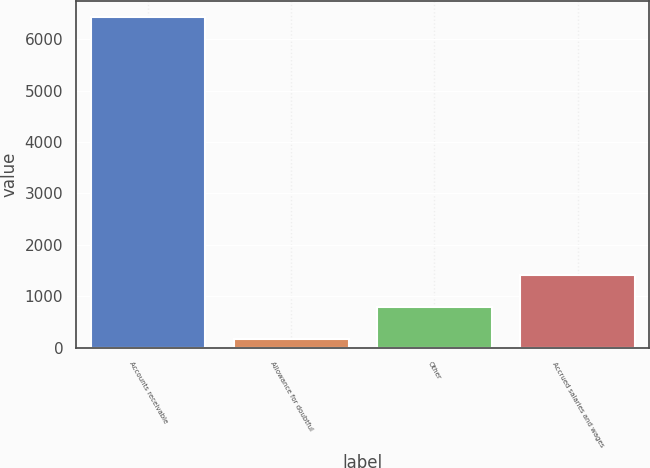Convert chart. <chart><loc_0><loc_0><loc_500><loc_500><bar_chart><fcel>Accounts receivable<fcel>Allowance for doubtful<fcel>Other<fcel>Accrued salaries and wages<nl><fcel>6426<fcel>166<fcel>792<fcel>1418<nl></chart> 